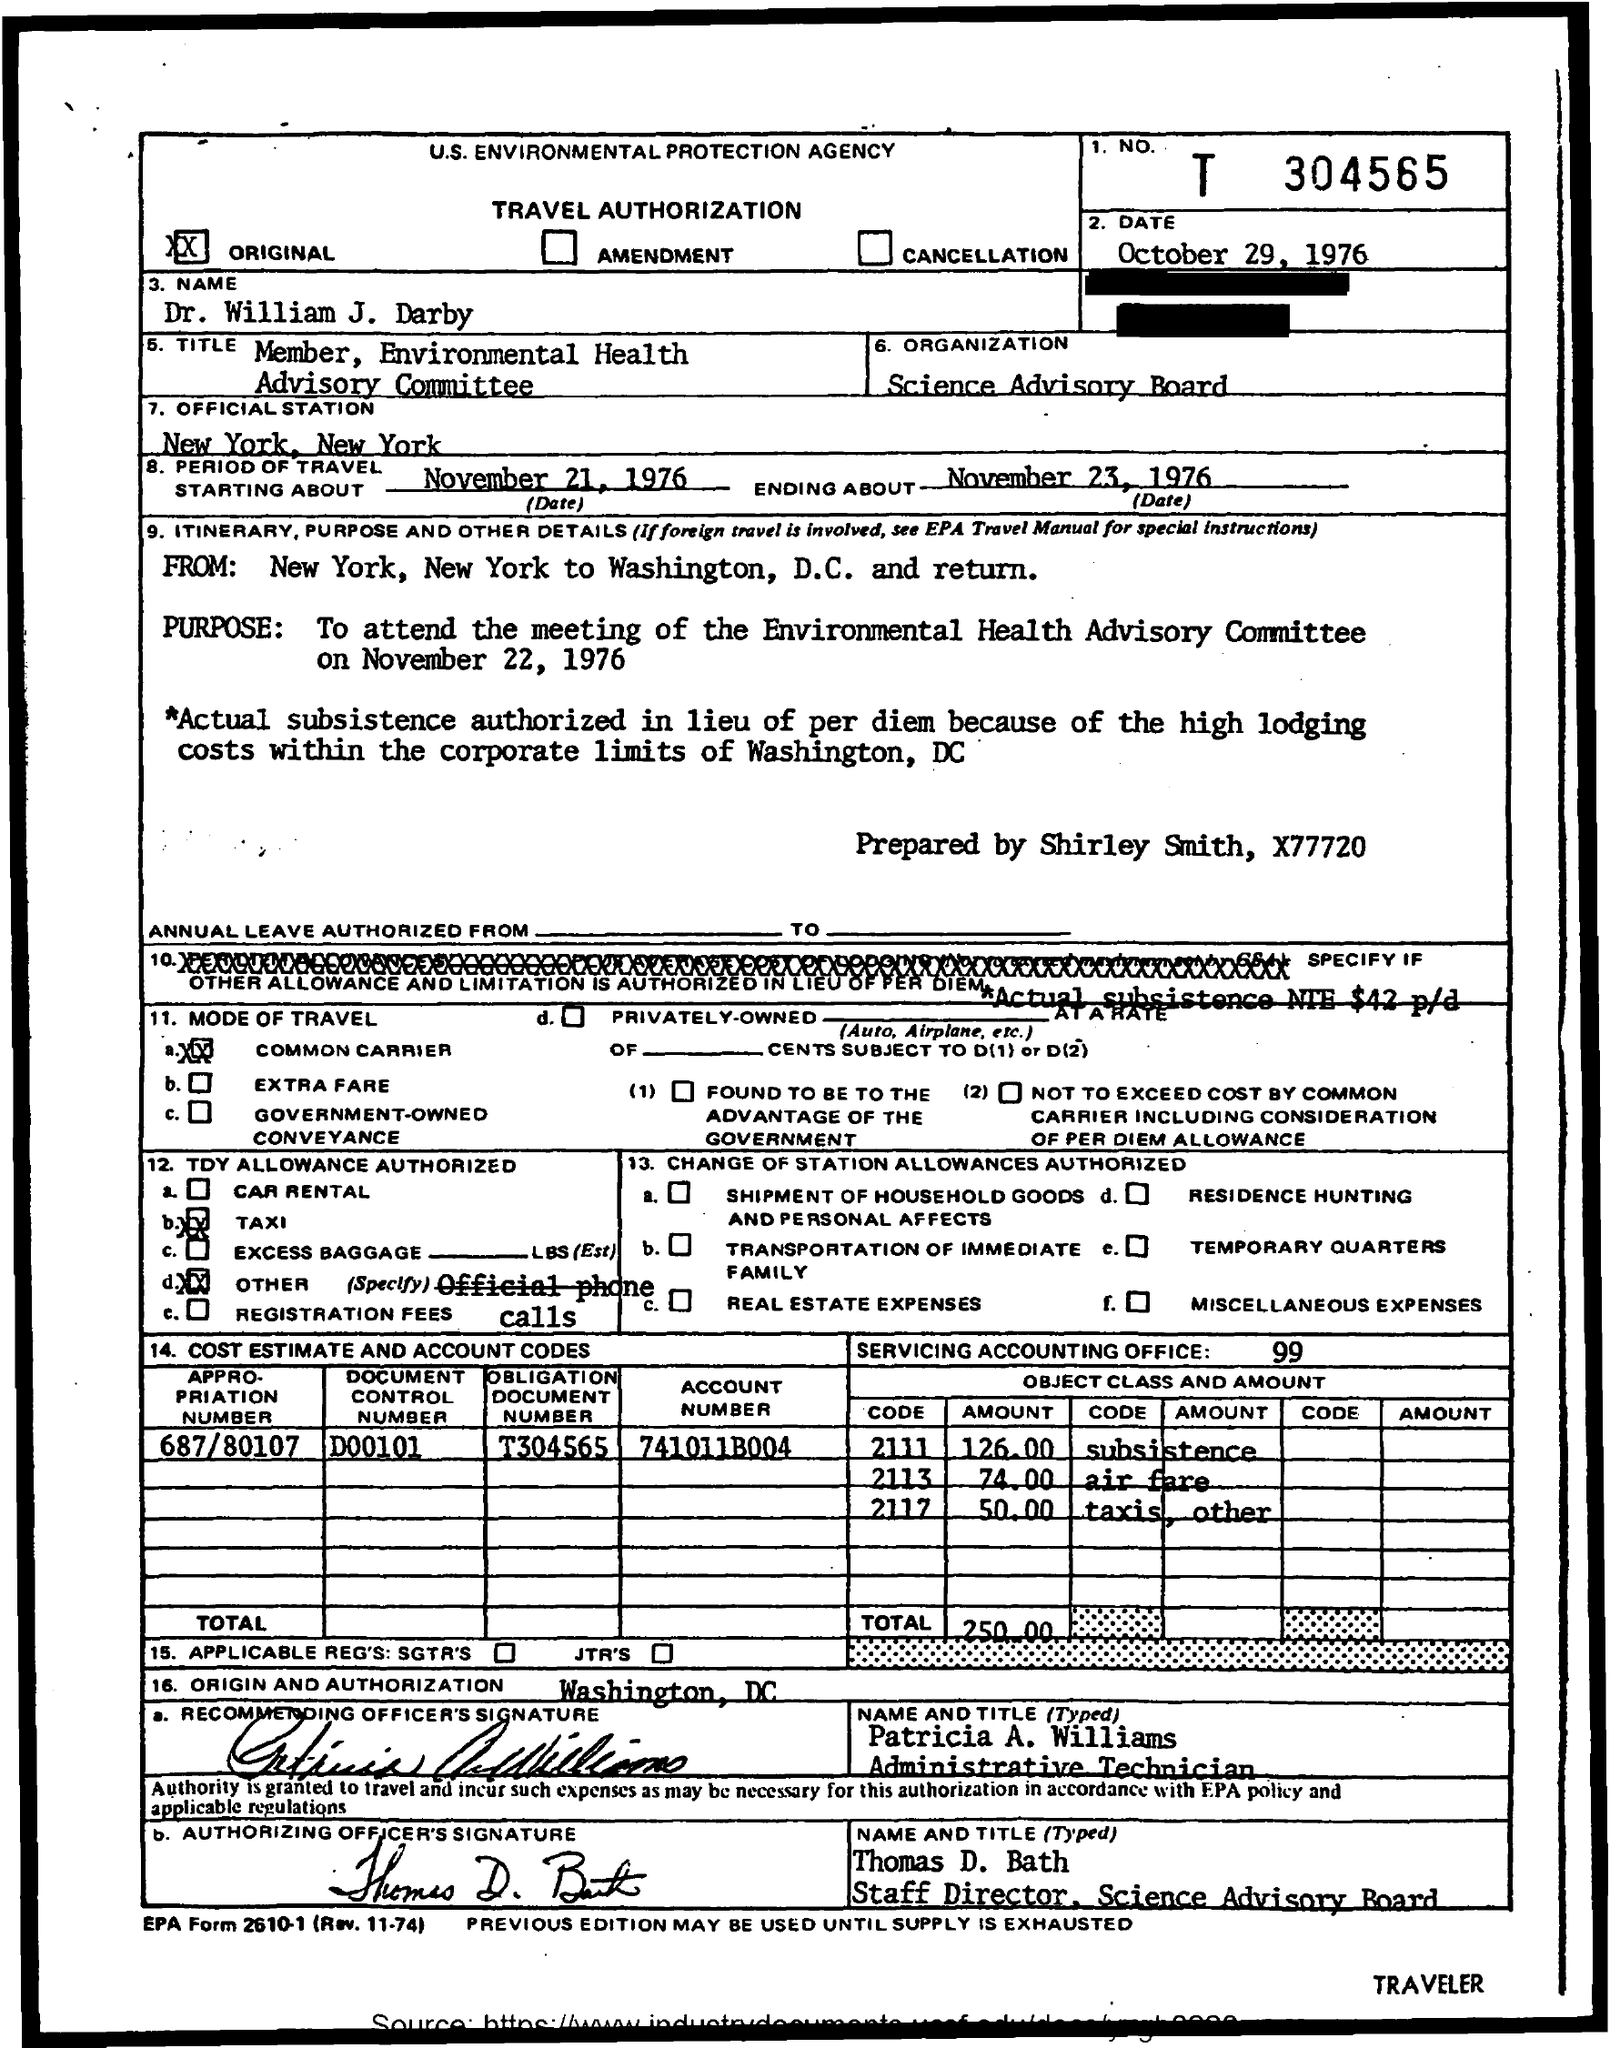Specify some key components in this picture. The meeting was held on November 22, 1976. The purpose of travel was to attend the meeting of the Environmental Health Advisory Committee on November 22, 1976. The period of travel start date is November 21, 1976. It is a travel authorization document. The preparation of the dish is done by Shirley Smith. 